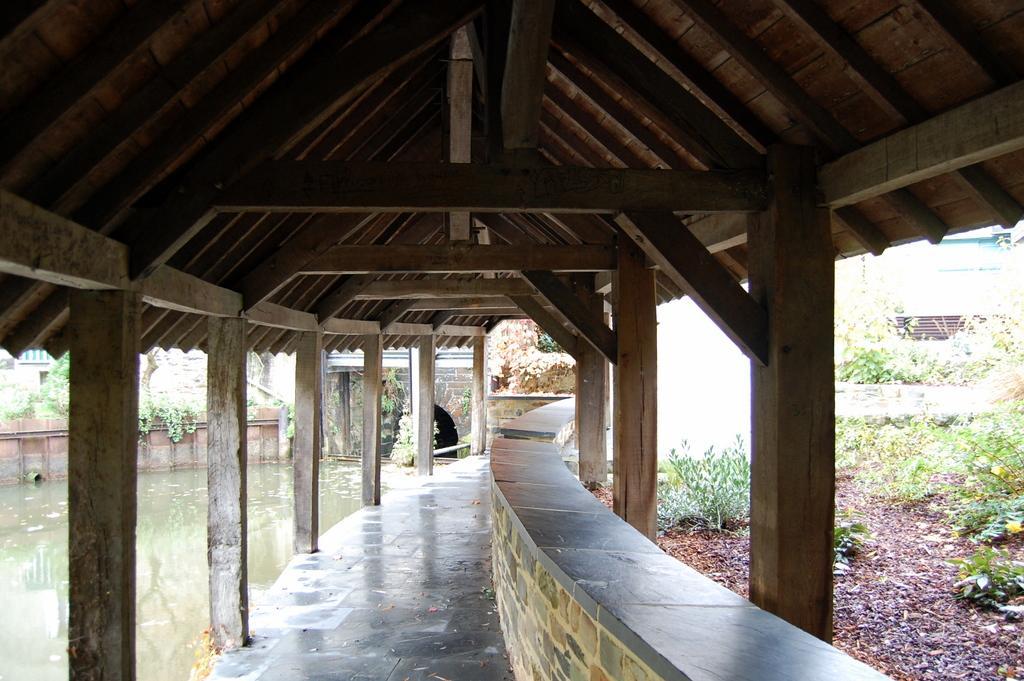How would you summarize this image in a sentence or two? In this picture we can see water, wall, and plants. There are wooden pillars and we can see roof. 